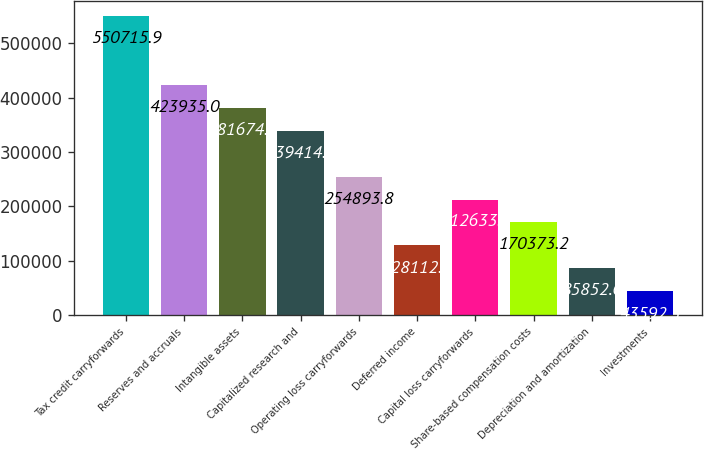Convert chart. <chart><loc_0><loc_0><loc_500><loc_500><bar_chart><fcel>Tax credit carryforwards<fcel>Reserves and accruals<fcel>Intangible assets<fcel>Capitalized research and<fcel>Operating loss carryforwards<fcel>Deferred income<fcel>Capital loss carryforwards<fcel>Share-based compensation costs<fcel>Depreciation and amortization<fcel>Investments<nl><fcel>550716<fcel>423935<fcel>381675<fcel>339414<fcel>254894<fcel>128113<fcel>212634<fcel>170373<fcel>85852.6<fcel>43592.3<nl></chart> 